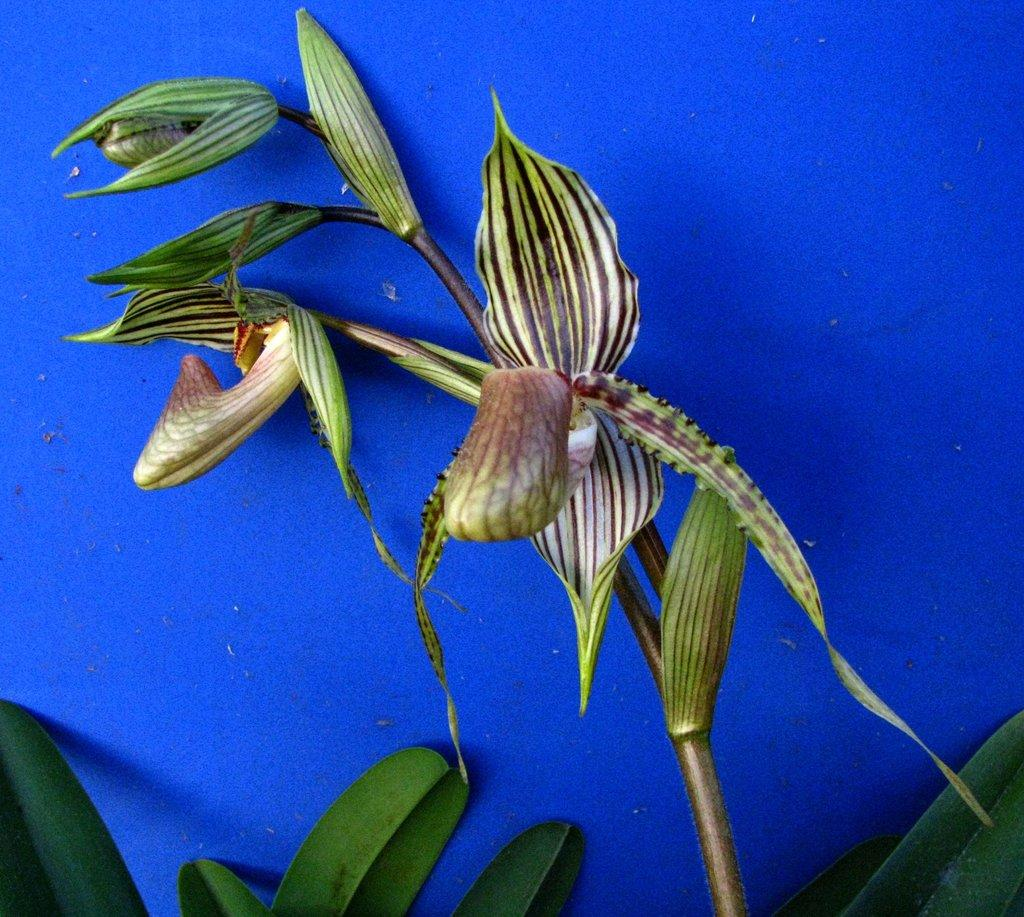What type of living organisms can be seen in the image? Plants can be seen in the image. What color is the background of the image? The background of the image is blue. What type of order is being processed in the image? There is no indication of any order being processed in the image, as it only features plants and a blue background. 